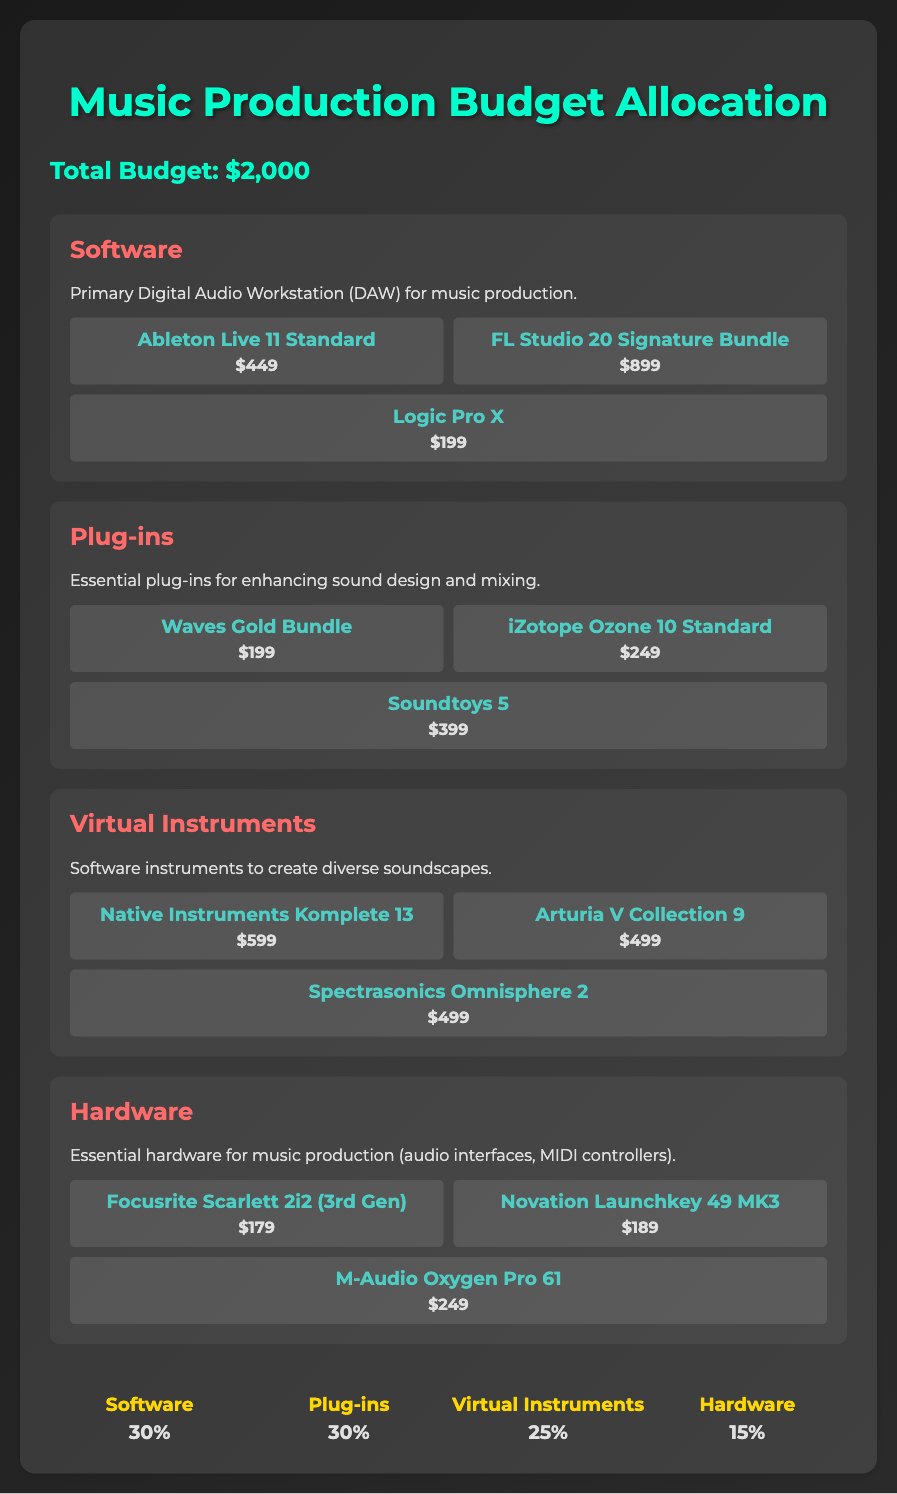What is the total budget? The total budget is provided prominently in the document as the overall amount available for allocation.
Answer: $2,000 How much does Ableton Live 11 Standard cost? The cost of Ableton Live 11 Standard is listed under the software section, showing its price directly.
Answer: $449 What percentage of the budget is allocated to Virtual Instruments? The budget allocation for Virtual Instruments is presented as a percentage in the budget distribution section of the document.
Answer: 25% Which plug-in has the highest cost? The costs of the various plug-ins are compared, and it is mentioned which one is the most expensive.
Answer: Soundtoys 5 What category does Logic Pro X belong to? Logic Pro X is mentioned under the specific type of software provided in the document.
Answer: Software How much is allocated for Hardware in percentage? The document provides a clear percentage of the total budget that is set aside for Hardware.
Answer: 15% What is the cost of the iZotope Ozone 10 Standard? The document specifies the price of the iZotope Ozone 10 Standard within the plug-in category.
Answer: $249 What is the total cost of all plug-ins listed? The document can be used to calculate the total of all individual plug-in prices provided in the list.
Answer: $847 